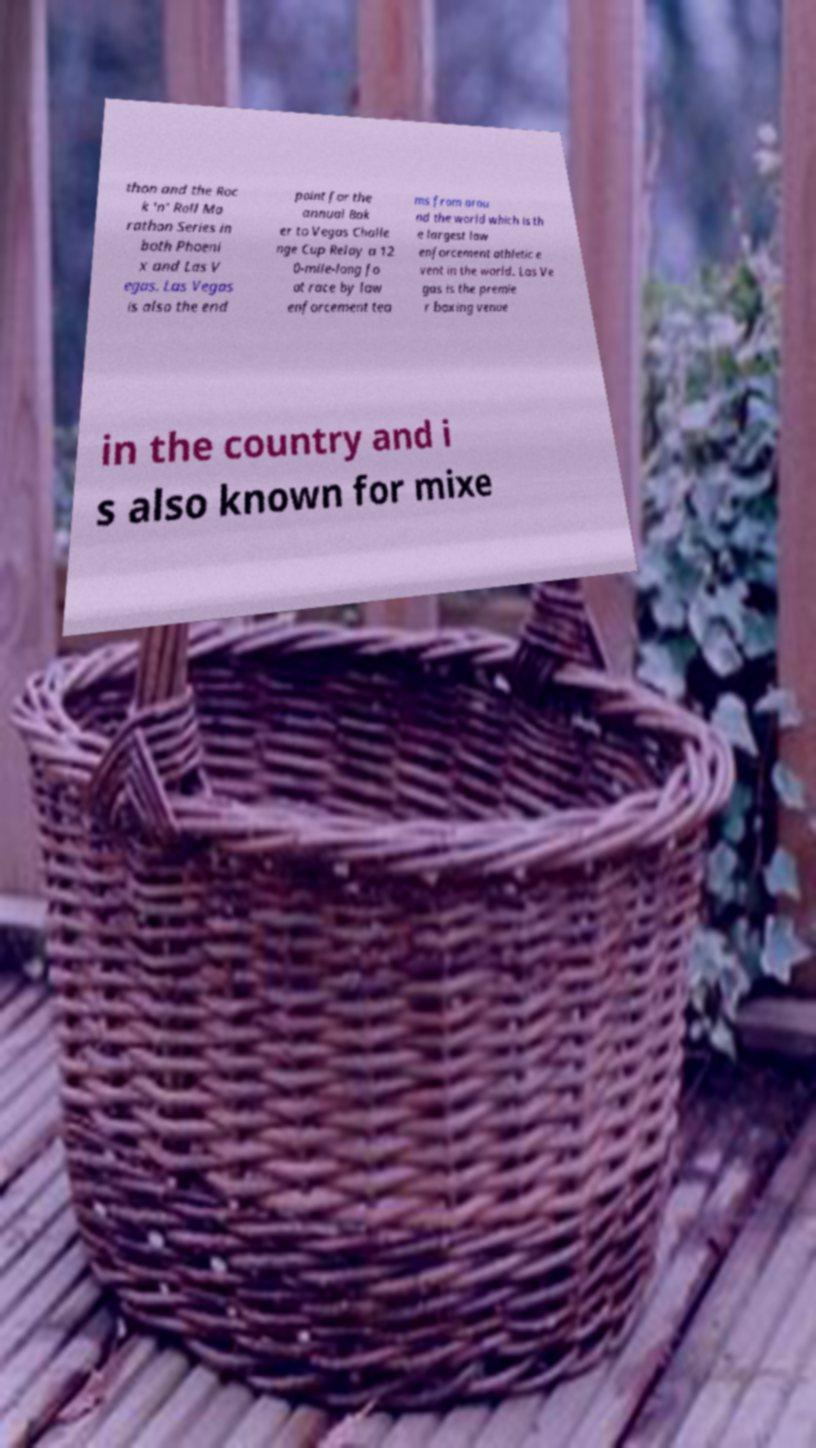Can you accurately transcribe the text from the provided image for me? thon and the Roc k 'n' Roll Ma rathon Series in both Phoeni x and Las V egas. Las Vegas is also the end point for the annual Bak er to Vegas Challe nge Cup Relay a 12 0-mile-long fo ot race by law enforcement tea ms from arou nd the world which is th e largest law enforcement athletic e vent in the world. Las Ve gas is the premie r boxing venue in the country and i s also known for mixe 